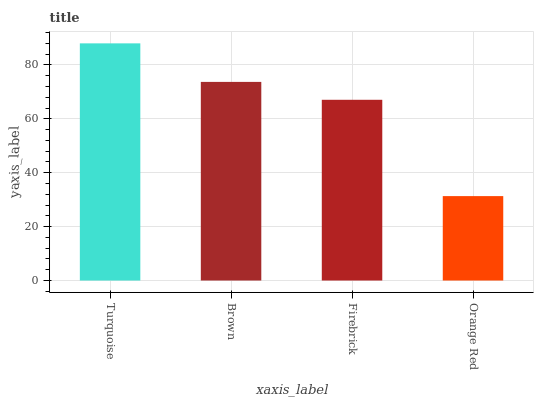Is Orange Red the minimum?
Answer yes or no. Yes. Is Turquoise the maximum?
Answer yes or no. Yes. Is Brown the minimum?
Answer yes or no. No. Is Brown the maximum?
Answer yes or no. No. Is Turquoise greater than Brown?
Answer yes or no. Yes. Is Brown less than Turquoise?
Answer yes or no. Yes. Is Brown greater than Turquoise?
Answer yes or no. No. Is Turquoise less than Brown?
Answer yes or no. No. Is Brown the high median?
Answer yes or no. Yes. Is Firebrick the low median?
Answer yes or no. Yes. Is Turquoise the high median?
Answer yes or no. No. Is Turquoise the low median?
Answer yes or no. No. 